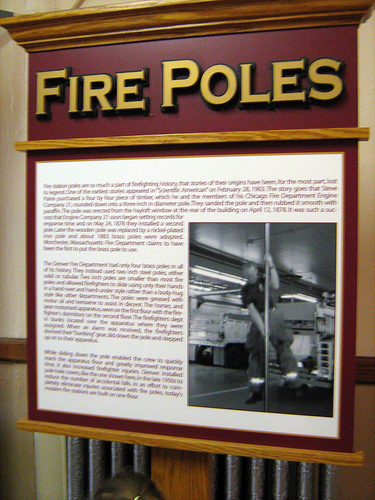<image>
Can you confirm if the photo is behind the board? No. The photo is not behind the board. From this viewpoint, the photo appears to be positioned elsewhere in the scene. 